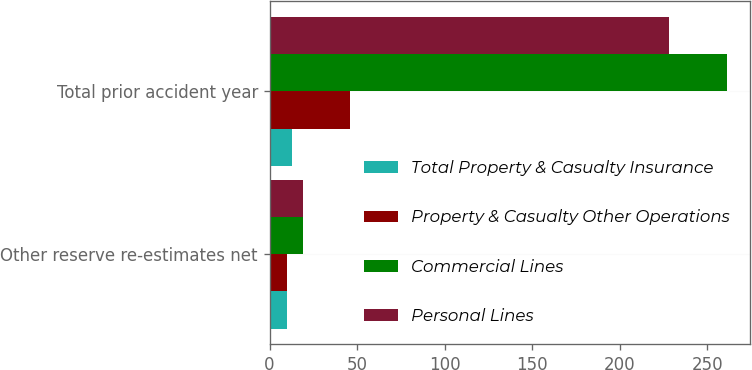<chart> <loc_0><loc_0><loc_500><loc_500><stacked_bar_chart><ecel><fcel>Other reserve re-estimates net<fcel>Total prior accident year<nl><fcel>Total Property & Casualty Insurance<fcel>10<fcel>13<nl><fcel>Property & Casualty Other Operations<fcel>10<fcel>46<nl><fcel>Commercial Lines<fcel>19<fcel>261<nl><fcel>Personal Lines<fcel>19<fcel>228<nl></chart> 